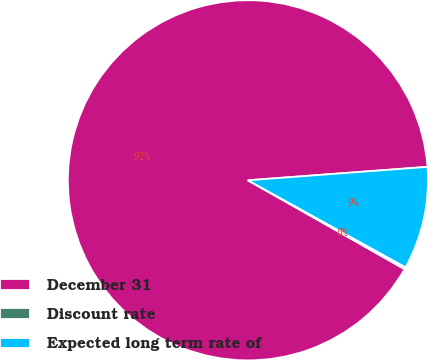<chart> <loc_0><loc_0><loc_500><loc_500><pie_chart><fcel>December 31<fcel>Discount rate<fcel>Expected long term rate of<nl><fcel>90.61%<fcel>0.18%<fcel>9.22%<nl></chart> 